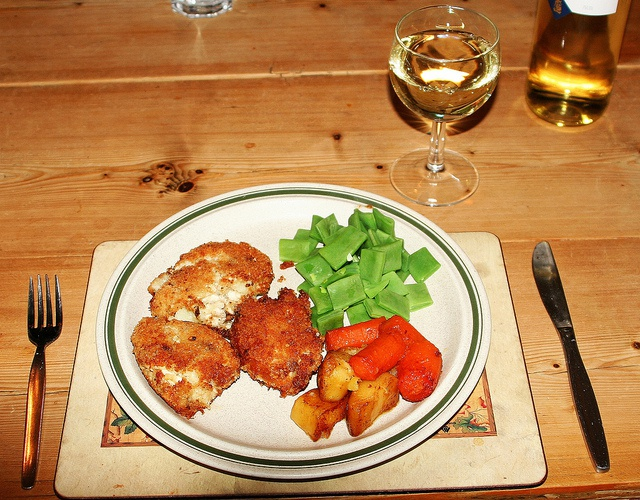Describe the objects in this image and their specific colors. I can see dining table in maroon, red, and orange tones, wine glass in maroon, brown, tan, and ivory tones, bottle in maroon, black, brown, and white tones, carrot in maroon, red, brown, and salmon tones, and knife in maroon, black, and gray tones in this image. 